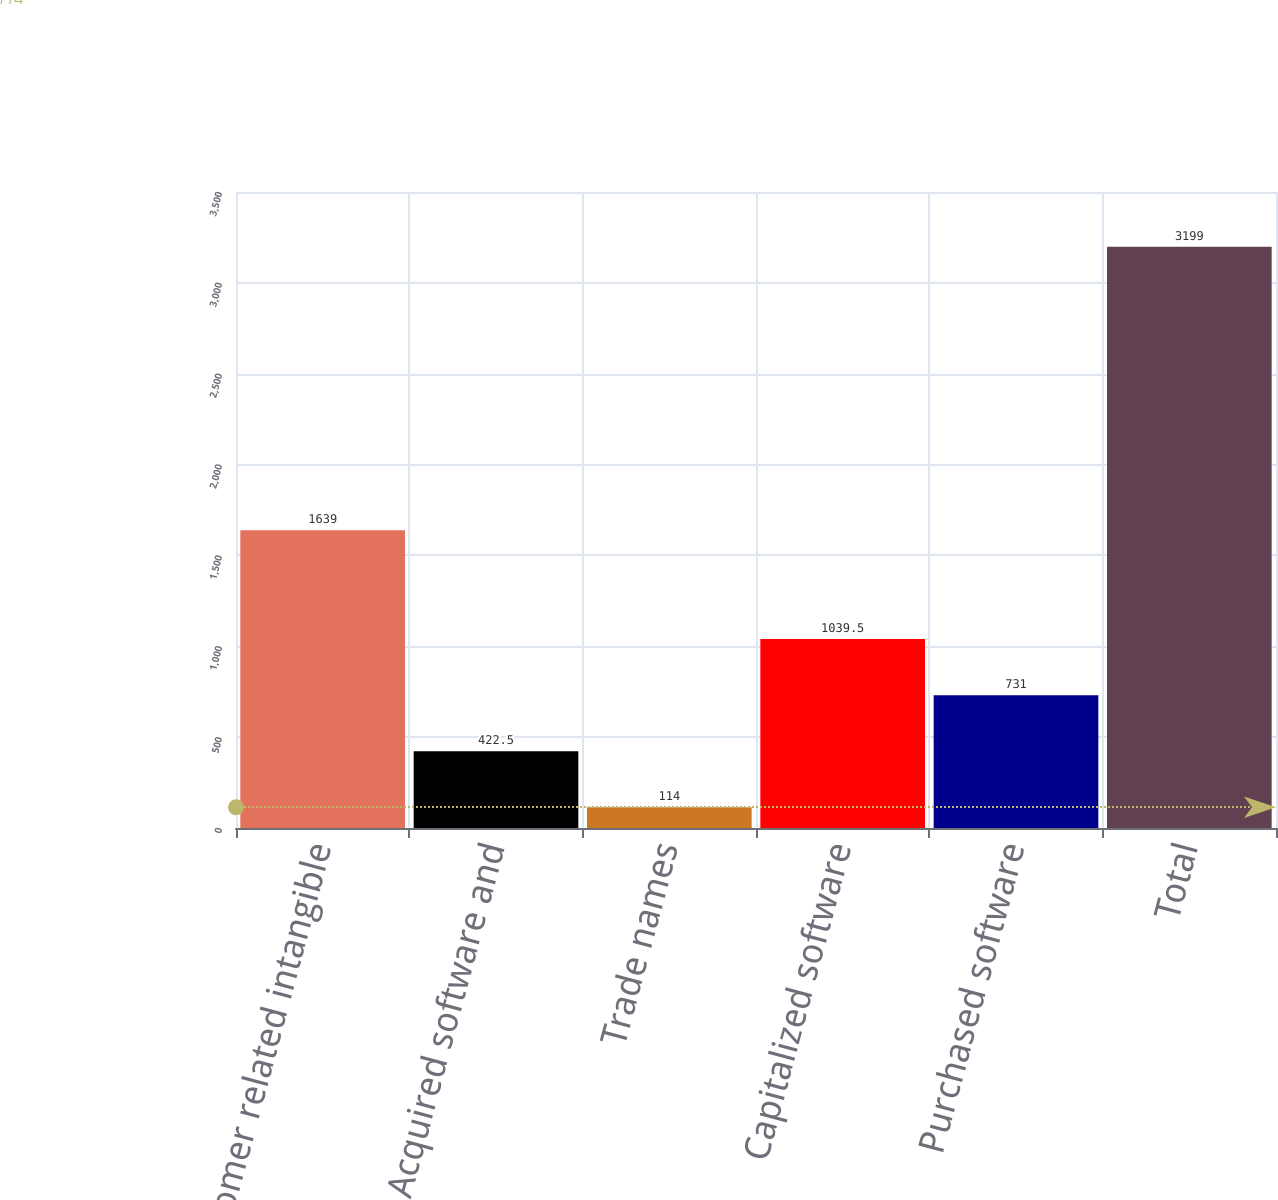Convert chart. <chart><loc_0><loc_0><loc_500><loc_500><bar_chart><fcel>Customer related intangible<fcel>Acquired software and<fcel>Trade names<fcel>Capitalized software<fcel>Purchased software<fcel>Total<nl><fcel>1639<fcel>422.5<fcel>114<fcel>1039.5<fcel>731<fcel>3199<nl></chart> 